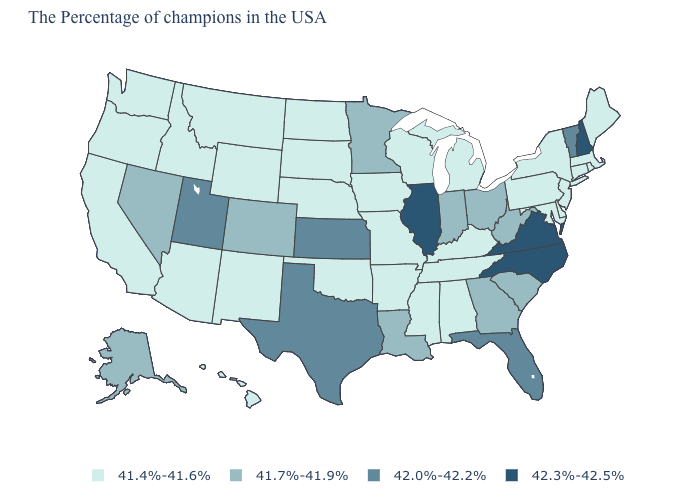Does Louisiana have the highest value in the South?
Answer briefly. No. Is the legend a continuous bar?
Concise answer only. No. What is the lowest value in the South?
Give a very brief answer. 41.4%-41.6%. What is the value of Wisconsin?
Concise answer only. 41.4%-41.6%. Name the states that have a value in the range 41.4%-41.6%?
Be succinct. Maine, Massachusetts, Rhode Island, Connecticut, New York, New Jersey, Delaware, Maryland, Pennsylvania, Michigan, Kentucky, Alabama, Tennessee, Wisconsin, Mississippi, Missouri, Arkansas, Iowa, Nebraska, Oklahoma, South Dakota, North Dakota, Wyoming, New Mexico, Montana, Arizona, Idaho, California, Washington, Oregon, Hawaii. Name the states that have a value in the range 42.3%-42.5%?
Write a very short answer. New Hampshire, Virginia, North Carolina, Illinois. What is the highest value in states that border Vermont?
Keep it brief. 42.3%-42.5%. Is the legend a continuous bar?
Be succinct. No. What is the value of Oregon?
Give a very brief answer. 41.4%-41.6%. Which states have the highest value in the USA?
Quick response, please. New Hampshire, Virginia, North Carolina, Illinois. Name the states that have a value in the range 41.4%-41.6%?
Short answer required. Maine, Massachusetts, Rhode Island, Connecticut, New York, New Jersey, Delaware, Maryland, Pennsylvania, Michigan, Kentucky, Alabama, Tennessee, Wisconsin, Mississippi, Missouri, Arkansas, Iowa, Nebraska, Oklahoma, South Dakota, North Dakota, Wyoming, New Mexico, Montana, Arizona, Idaho, California, Washington, Oregon, Hawaii. What is the value of North Carolina?
Keep it brief. 42.3%-42.5%. Name the states that have a value in the range 42.3%-42.5%?
Answer briefly. New Hampshire, Virginia, North Carolina, Illinois. What is the highest value in the USA?
Keep it brief. 42.3%-42.5%. 